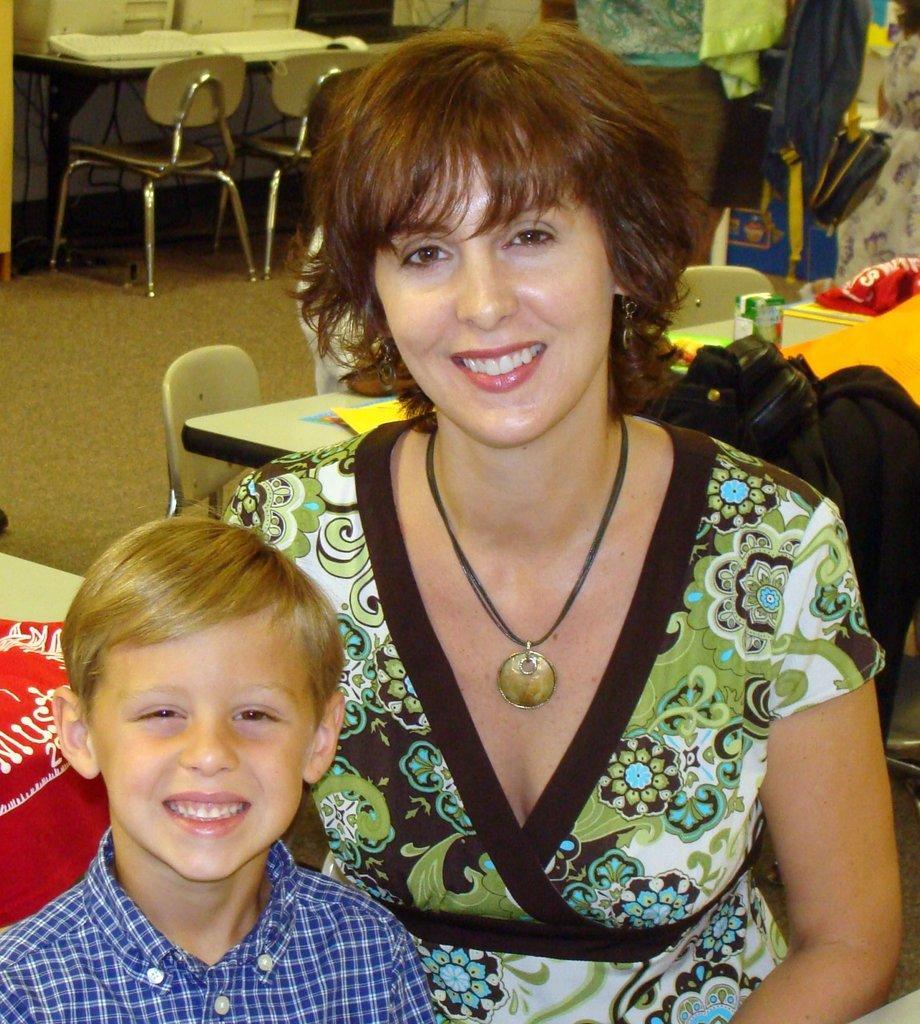How would you summarize this image in a sentence or two? There is a woman and a boy. They are smiling. This is table and there are chairs. This is floor. 